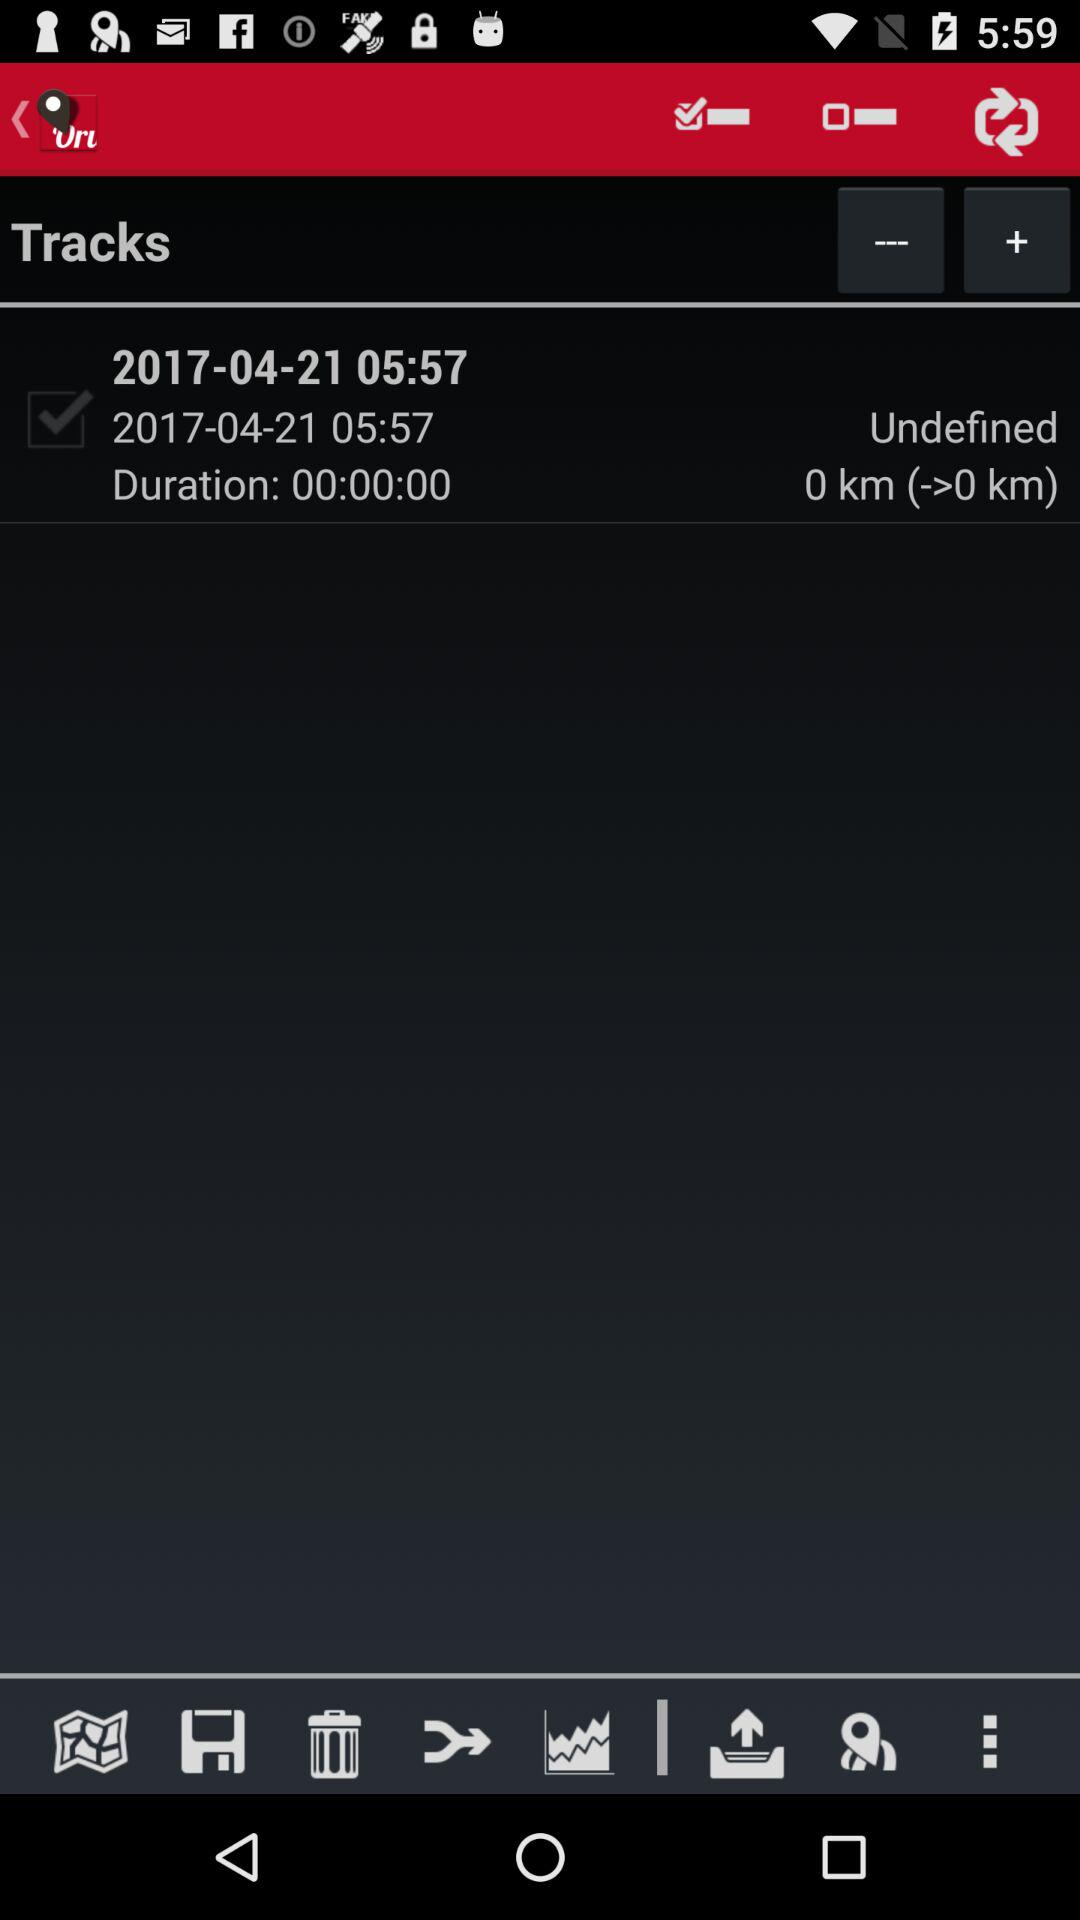What is the date? The date is April 21, 2017. 